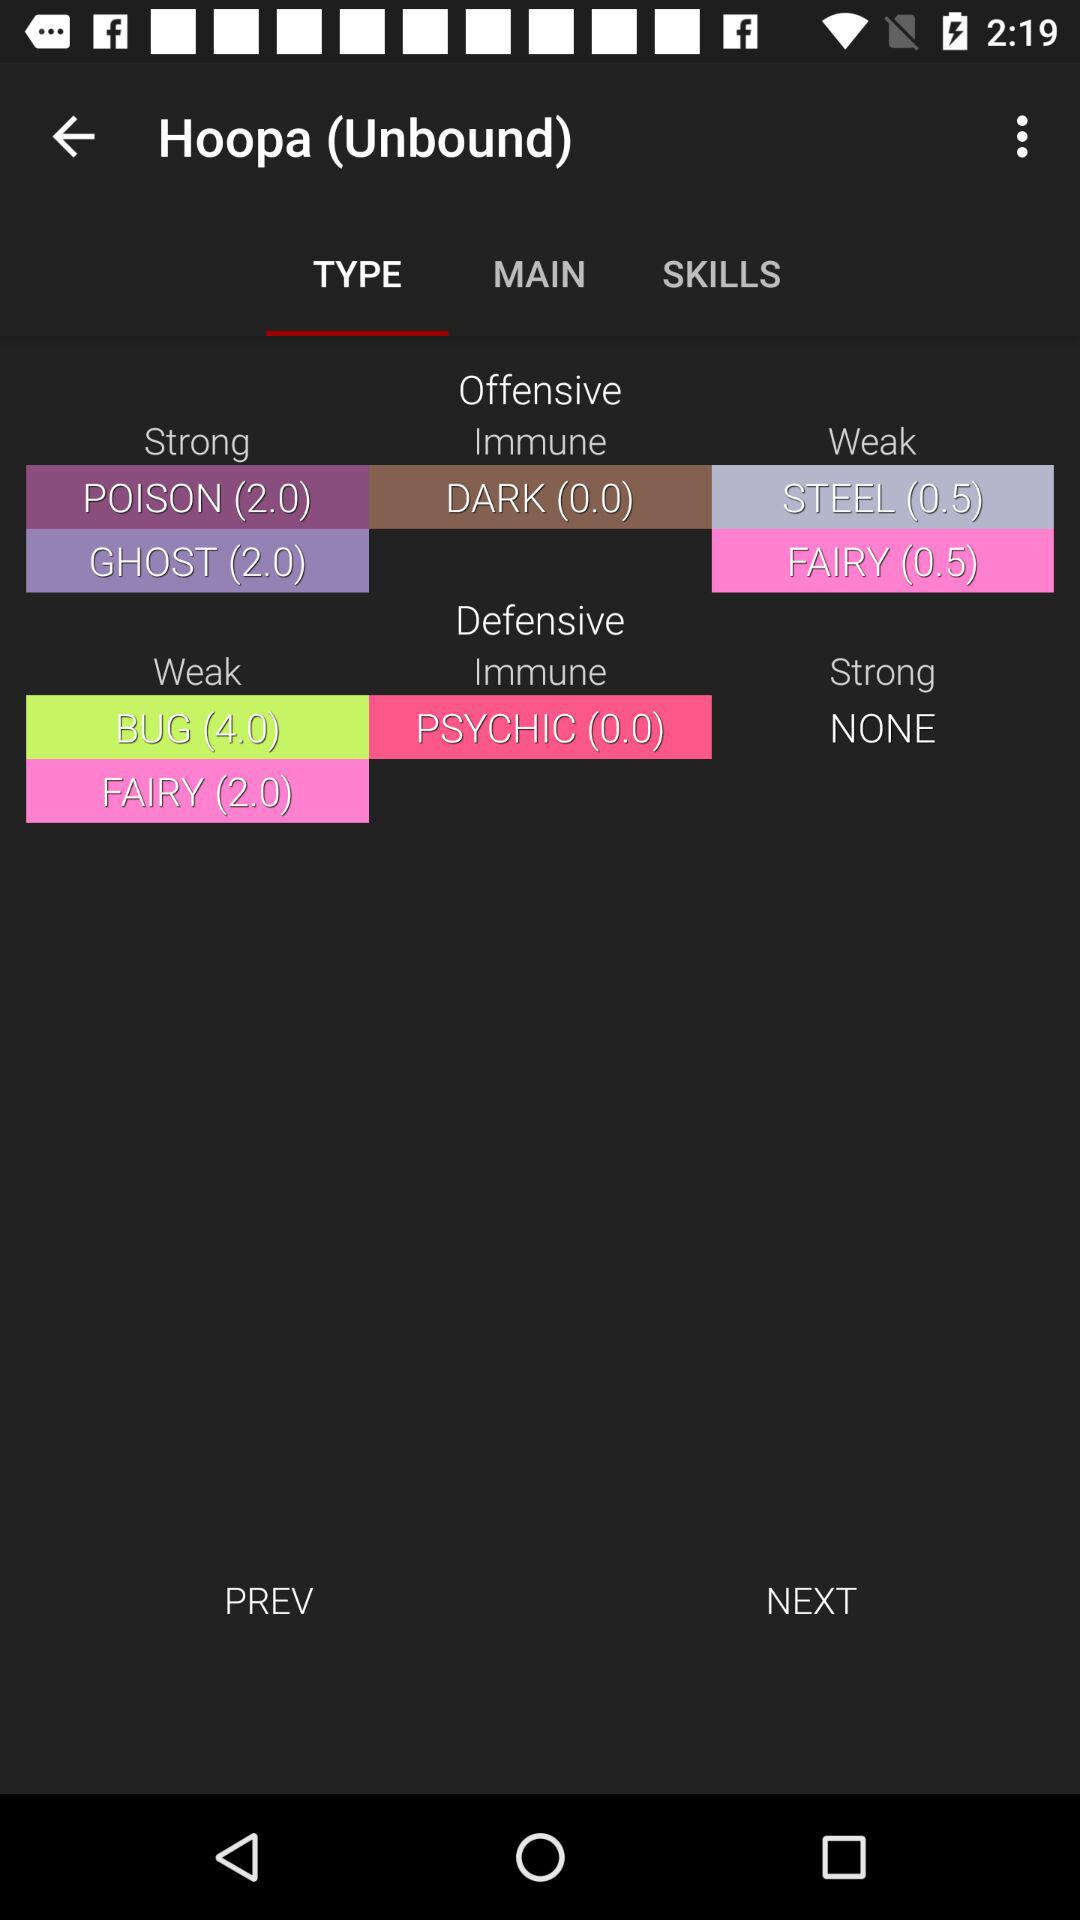What are the offensive points of "Hoopa (Unbound)" against "POISON" in the "Strong" category? The offensive points of "Hoopa (Unbound)" against "POISON" in the "Strong" category are 2. 